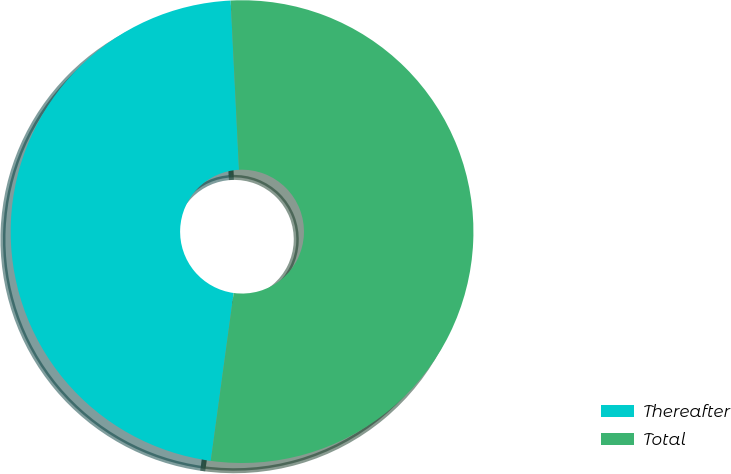Convert chart. <chart><loc_0><loc_0><loc_500><loc_500><pie_chart><fcel>Thereafter<fcel>Total<nl><fcel>47.06%<fcel>52.94%<nl></chart> 